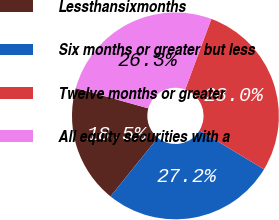Convert chart to OTSL. <chart><loc_0><loc_0><loc_500><loc_500><pie_chart><fcel>Lessthansixmonths<fcel>Six months or greater but less<fcel>Twelve months or greater<fcel>All equity securities with a<nl><fcel>18.53%<fcel>27.16%<fcel>27.99%<fcel>26.32%<nl></chart> 